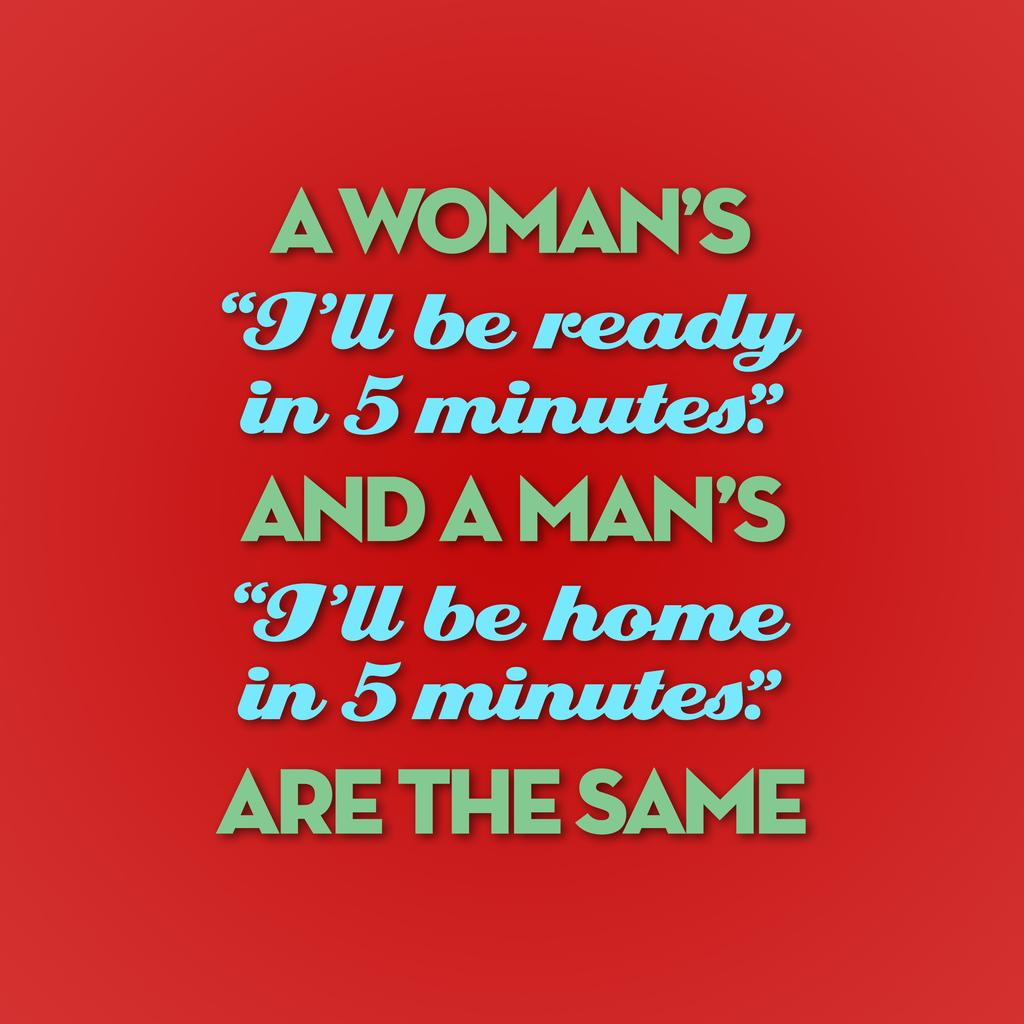<image>
Summarize the visual content of the image. A poster that starts with "A Woman's 'I'll be ready in 5 minutes...'" 